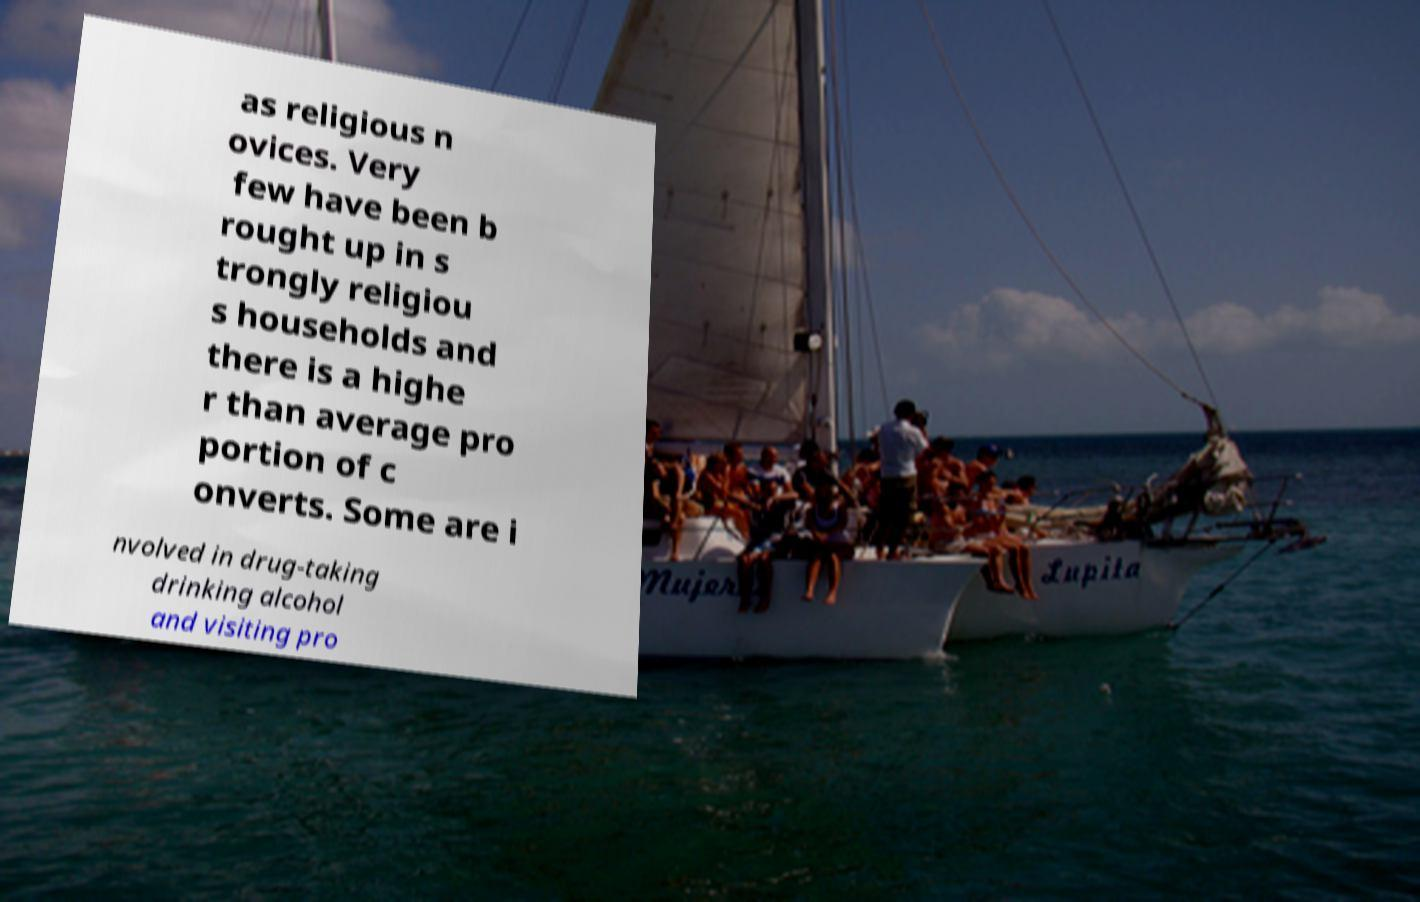There's text embedded in this image that I need extracted. Can you transcribe it verbatim? as religious n ovices. Very few have been b rought up in s trongly religiou s households and there is a highe r than average pro portion of c onverts. Some are i nvolved in drug-taking drinking alcohol and visiting pro 